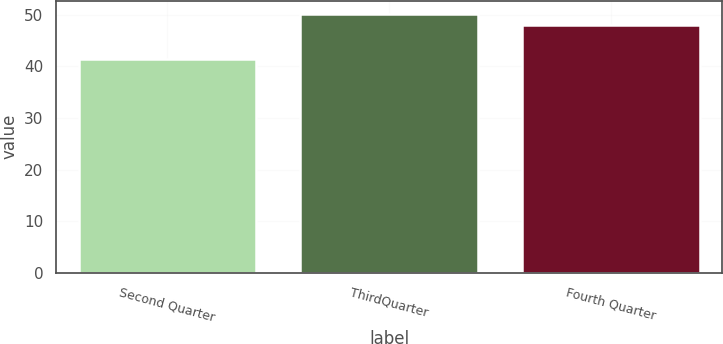Convert chart to OTSL. <chart><loc_0><loc_0><loc_500><loc_500><bar_chart><fcel>Second Quarter<fcel>ThirdQuarter<fcel>Fourth Quarter<nl><fcel>41.37<fcel>50.21<fcel>47.96<nl></chart> 